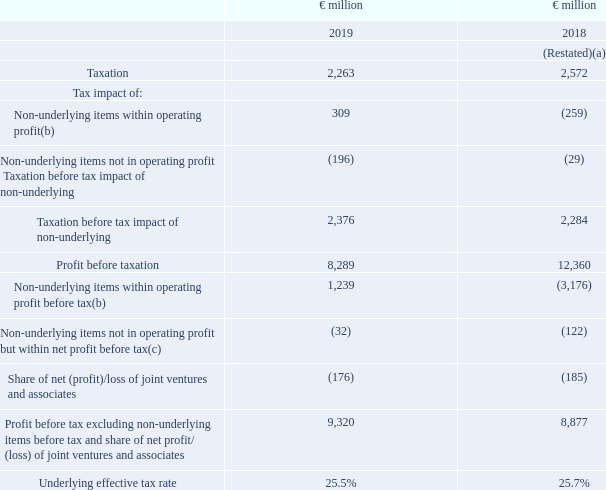Underlying effective tax rate
The underlying effective tax rate is calculated by dividing taxation excluding the tax impact of non-underlying items by profit before tax excluding the impact of non-underlying items and share of net profit/(loss) of joint ventures and associates. This measure reflects the underlying tax rate in relation to profit before tax excluding non-underlying items before tax and share of net profit/(loss) of joint ventures and associates.
Tax impact on non-underlying items within operating profit is the sum of the tax on each non-underlying item, based on the applicable country tax rates and tax treatment. This is shown in the table:
(a) Restated following adoption of IFRS 16. See note 1 and note 24 for further details.
(b) Refer to note 3 for further details on these items.
(c) Excludes €3 million (2018: €32 million) gain on disposal of spreads business by the joint venture in Portugal which is included in the share of net profit/(loss) of joint ventures and associates line. Including the gain, total non-underlying items not in operating profit but within net profit before tax is €35 million (2018: €154 million). See note 3.
What does the underlying effective tax rate measure reflects? Reflects the underlying tax rate in relation to profit before tax excluding non-underlying items before tax and share of net profit/(loss) of joint ventures and associates. How is the underlying effective tax rate calculated? Dividing taxation excluding the tax impact of non-underlying items by profit before tax excluding the impact of non-underlying items and share of net profit/(loss) of joint ventures and associates. How is the tax impact on non underlying items within operating profit calculated? Sum of the tax on each non-underlying item, based on the applicable country tax rates and tax treatment. What is the increase / (decrease) in Profit before taxation from 2018 to 2019?
Answer scale should be: million. 8,289 - 12,360
Answer: -4071. What is the Underlying effective tax rate change from 2018 to 2019?
Answer scale should be: percent. 25.5 - 25.7
Answer: -0.2. What is the average taxation?
Answer scale should be: million. (2,263 + 2,572) / 2
Answer: 2417.5. 